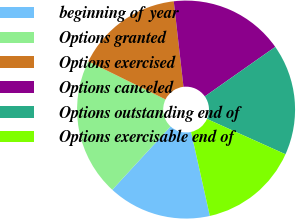<chart> <loc_0><loc_0><loc_500><loc_500><pie_chart><fcel>beginning of year<fcel>Options granted<fcel>Options exercised<fcel>Options canceled<fcel>Options outstanding end of<fcel>Options exercisable end of<nl><fcel>15.34%<fcel>20.45%<fcel>15.91%<fcel>17.05%<fcel>16.48%<fcel>14.77%<nl></chart> 